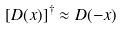Convert formula to latex. <formula><loc_0><loc_0><loc_500><loc_500>[ { D } ( x ) ] ^ { \dagger } \approx { D } ( - x )</formula> 